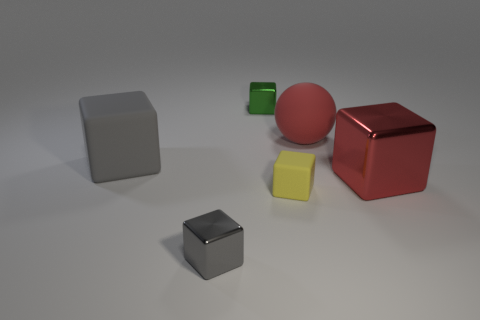Subtract all gray cubes. How many were subtracted if there are1gray cubes left? 1 Subtract all yellow cubes. Subtract all brown balls. How many cubes are left? 4 Add 1 rubber balls. How many objects exist? 7 Subtract all balls. How many objects are left? 5 Subtract all big metal spheres. Subtract all red blocks. How many objects are left? 5 Add 6 big shiny blocks. How many big shiny blocks are left? 7 Add 5 big blue shiny things. How many big blue shiny things exist? 5 Subtract 0 yellow spheres. How many objects are left? 6 